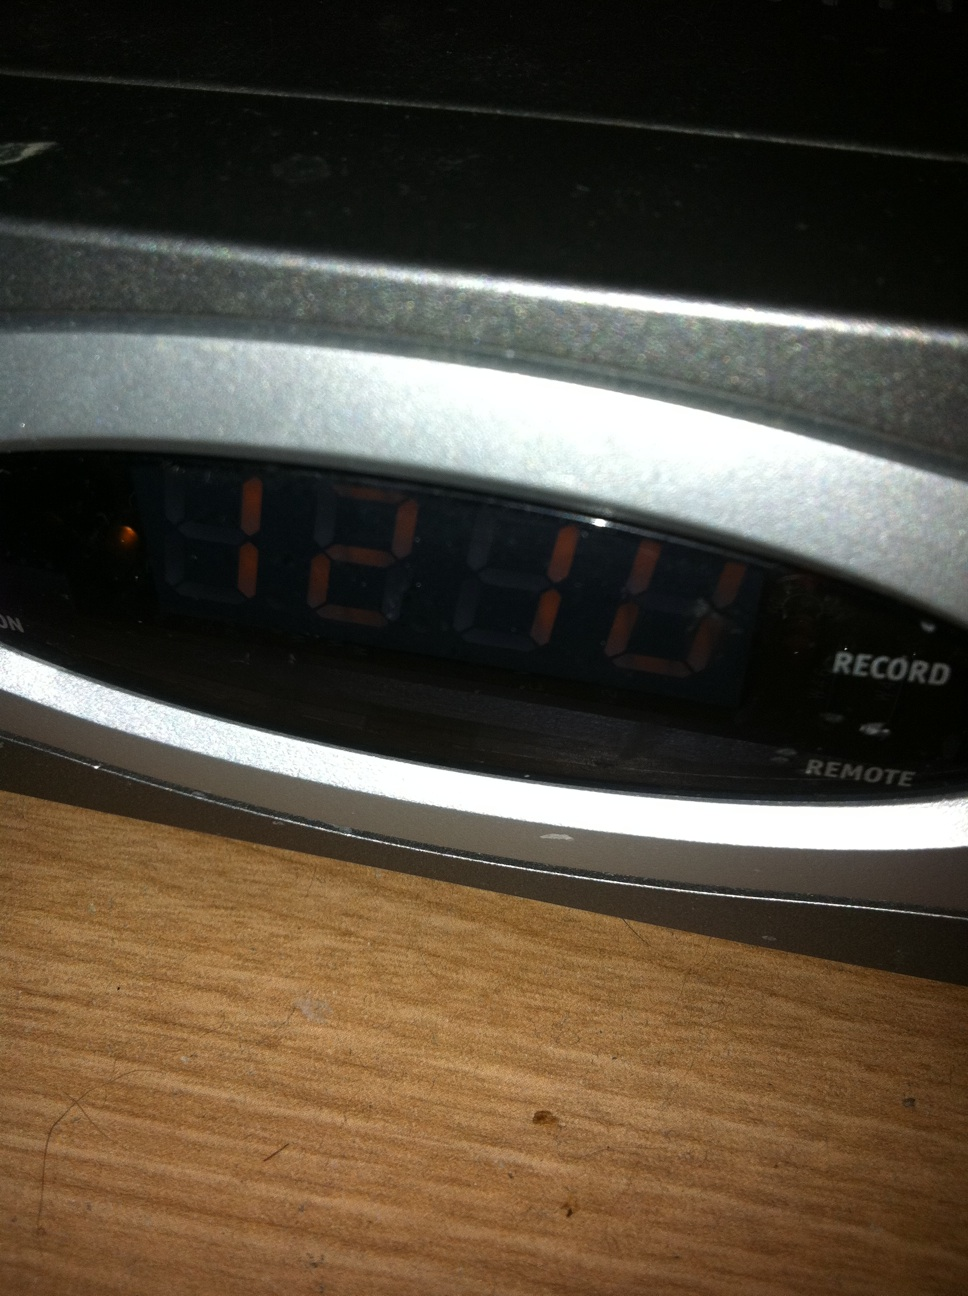What are some possible technical issues that could arise with this set-top box? Some possible technical issues that could arise with the set-top box include: the display malfunctioning, showing incorrect or garbled time; recording failures where scheduled programs do not get recorded; connectivity issues with the remote control; software glitches that may cause it to freeze or reboot unexpectedly; and potential hard drive failures, especially if it has an internal storage for recordings. Regular maintenance and updates can help mitigate many of these issues. If the set-top box stops showing the correct time, what troubleshooting steps might you recommend? If the set-top box stops showing the correct time, you might try the following troubleshooting steps:
1. **Restart the Device:** Turn off the set-top box, wait a few seconds, and then turn it back on.
2. **Check the Power Source:** Ensure the set-top box is securely plugged in and receiving power.
3. **Reset the Clock:** Access the settings menu and manually set the correct time.
4. **Firmware Update:** Check if there is a firmware update available that might fix any current issues.
5. **Factory Reset:** As a last resort, perform a factory reset. Note that this will erase all preferences and recorded content, so use this option cautiously.
If these steps do not resolve the issue, you may need to contact customer support for further assistance. Imagine if an alien used this set-top box. What unusual problems might they encounter? If an alien used this set-top box, they might encounter problems such as misunderstanding the human concept of time, leading to confusion over scheduling recordings. The alien might also have issues with the remote control if it's designed for human hands and infrared signals, which they may not be familiar with. Additionally, the alien could face difficulties interpreting the content being recorded, especially if the shows depict purely human-centric topics or humor. They might need to adjust to the format of our entertainment and communication signals, leading to initial operational hiccups. Describe a scenario where a family uses this set-top box on a movie night. On a cozy Friday night, a family gathers around their living room for movie night. The kids quickly settle on the couch with popcorn in hand while the parents use the set-top box to navigate through their library of recorded movies. They pick a family favorite that was recorded a few nights ago. Using the remote control, they select the movie, adjust the volume, and hit play. Throughout the movie, they can pause to get more snacks or rewind to re-watch funny moments. The set-top box's DVR feature ensures that they have a seamless and enjoyable movie-watching experience without commercials, making it a memorable family tradition. How might someone use this set-top box in a time-crunch situation to catch up on their favorite series? In a time-crunch situation, someone could use the set-top box to quickly catch up on their favorite series by accessing the recorded episodes menu. By using fast-forward and skip features, they can breeze through commercials and recap segments, focusing only on new content. This efficiency allows them to stay updated on the series storyline even with limited available time. 